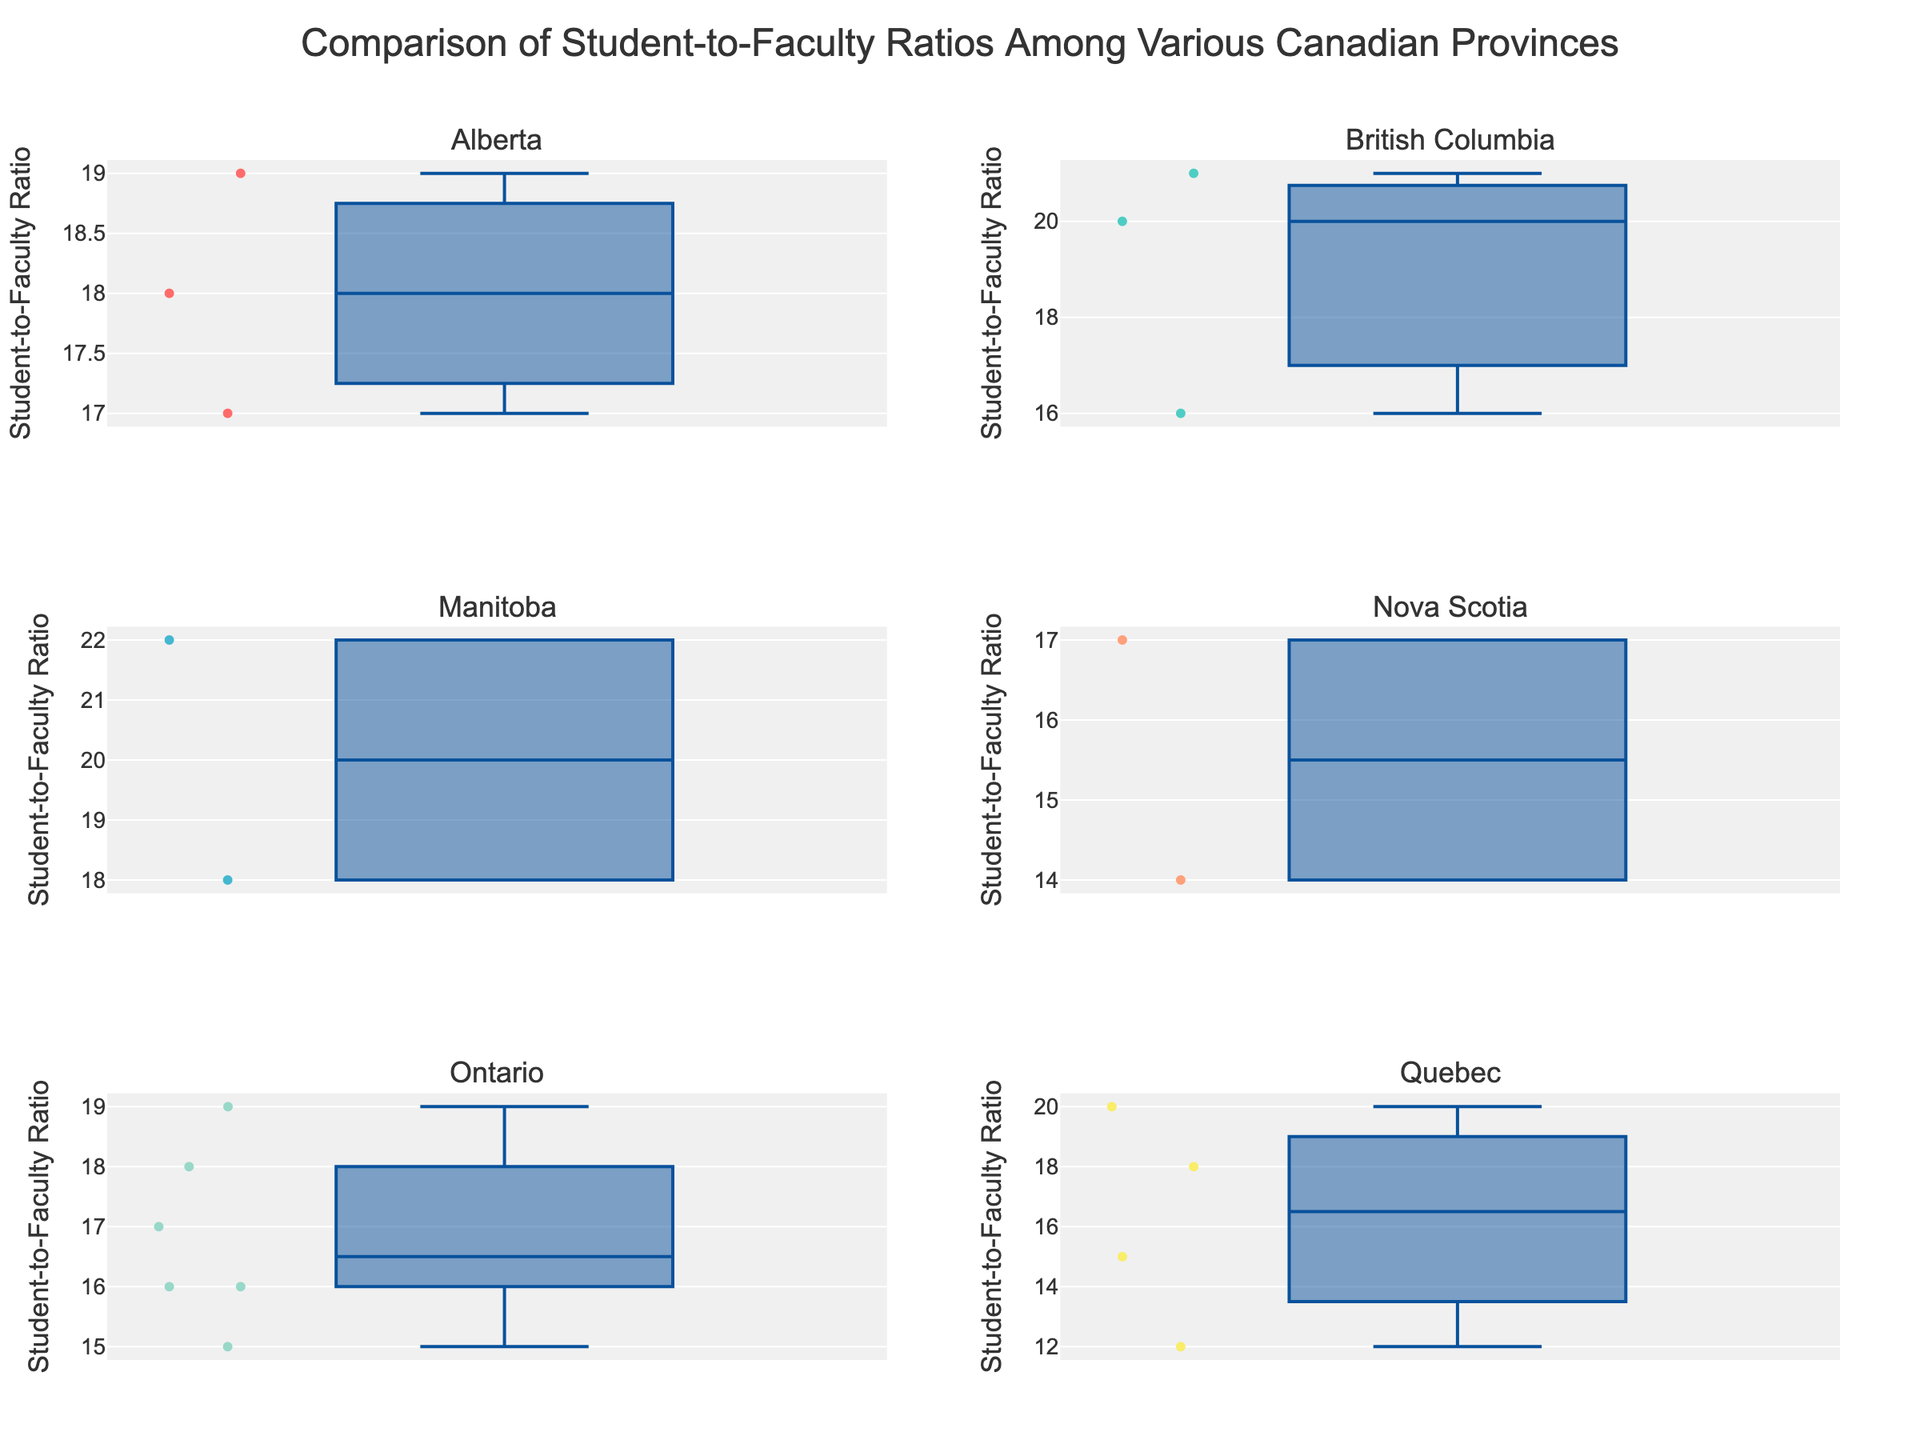What's the highest student-to-faculty ratio in Quebec? In the Quebec subplot, the box plot represents the distribution of student-to-faculty ratios for universities in Quebec. We see that the highest point (outliers included) corresponds to 20.
Answer: 20 Which province has the lowest median student-to-faculty ratio? To determine the province with the lowest median, look at the central line inside each box plot, which represents the median value. Quebec's median is the lowest, as it is closest to the bottom of the plot.
Answer: Quebec In which subplot do we see the widest range of student-to-faculty ratios? The range of each subplot can be observed from the minimum to the maximum values including the outliers. Manitoba shows the widest range with ratios spanning from 18 to 22.
Answer: Manitoba How does the median student-to-faculty ratio in Ontario compare to that in Alberta? The median is the line in the center of each box plot. Comparing Ontario's and Alberta's medians, we see that Ontario's median (17) is lower than Alberta's median (18).
Answer: Ontario's median is lower Which provinces have universities with student-to-faculty ratios represented by outliers in their subplots? Outliers are the points that fall outside the whiskers of the box plots. British Columbia and Quebec have universities with outlying student-to-faculty ratios.
Answer: British Columbia and Quebec 